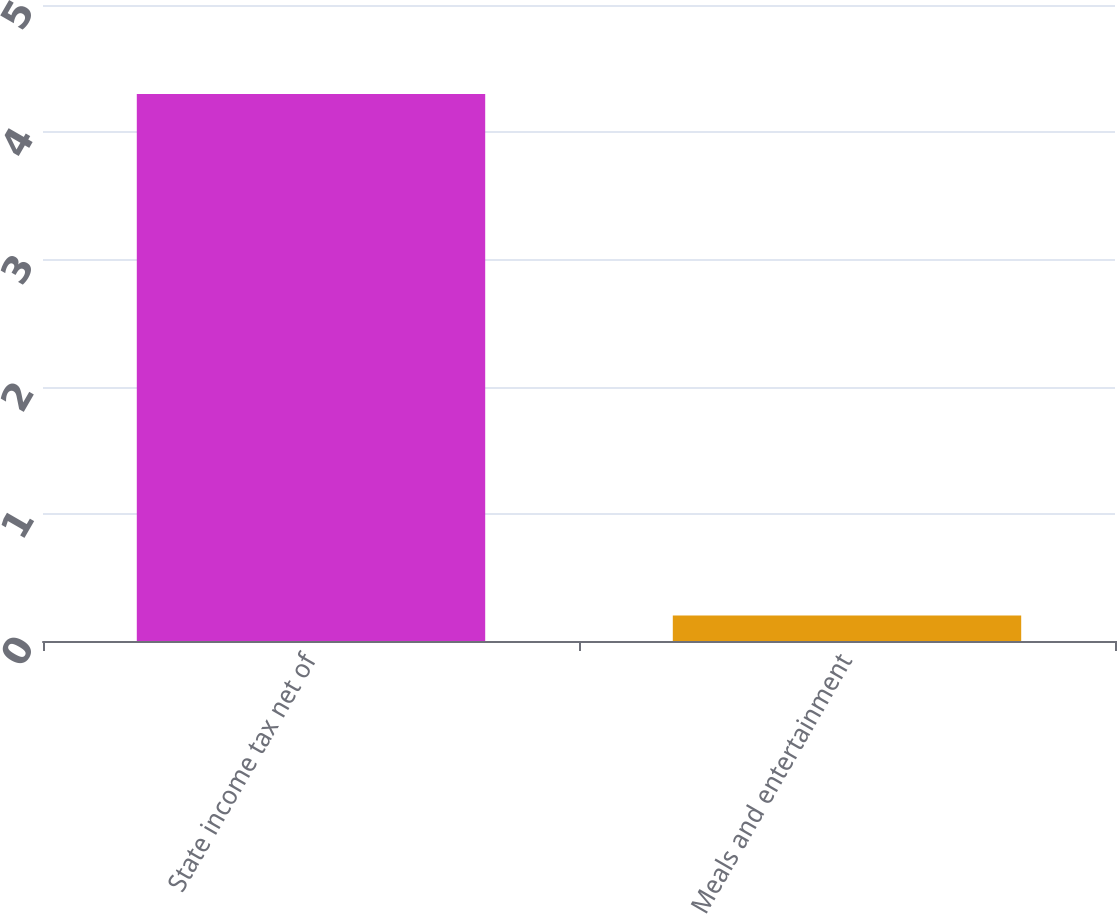Convert chart to OTSL. <chart><loc_0><loc_0><loc_500><loc_500><bar_chart><fcel>State income tax net of<fcel>Meals and entertainment<nl><fcel>4.3<fcel>0.2<nl></chart> 